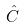Convert formula to latex. <formula><loc_0><loc_0><loc_500><loc_500>\hat { C }</formula> 